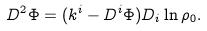<formula> <loc_0><loc_0><loc_500><loc_500>D ^ { 2 } \Phi = ( k ^ { i } - D ^ { i } \Phi ) D _ { i } \ln \rho _ { 0 } .</formula> 